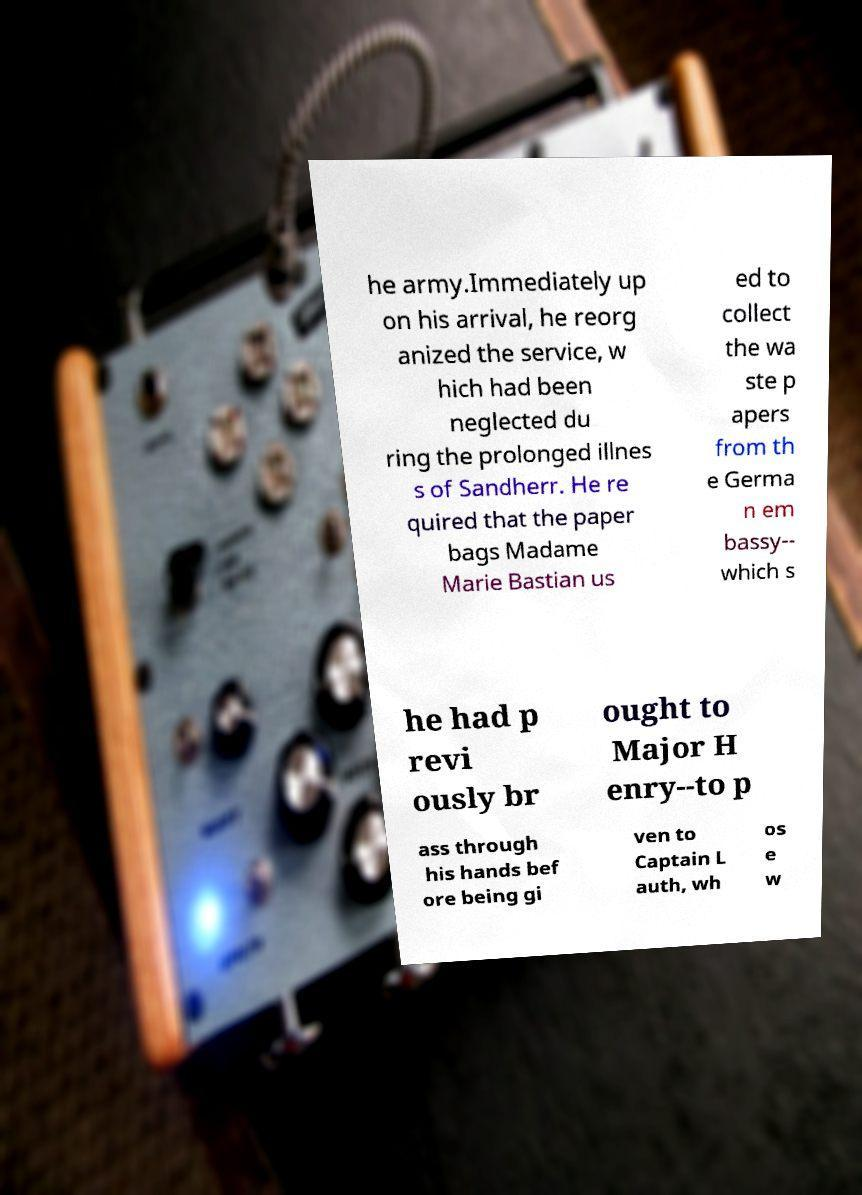There's text embedded in this image that I need extracted. Can you transcribe it verbatim? he army.Immediately up on his arrival, he reorg anized the service, w hich had been neglected du ring the prolonged illnes s of Sandherr. He re quired that the paper bags Madame Marie Bastian us ed to collect the wa ste p apers from th e Germa n em bassy-- which s he had p revi ously br ought to Major H enry--to p ass through his hands bef ore being gi ven to Captain L auth, wh os e w 